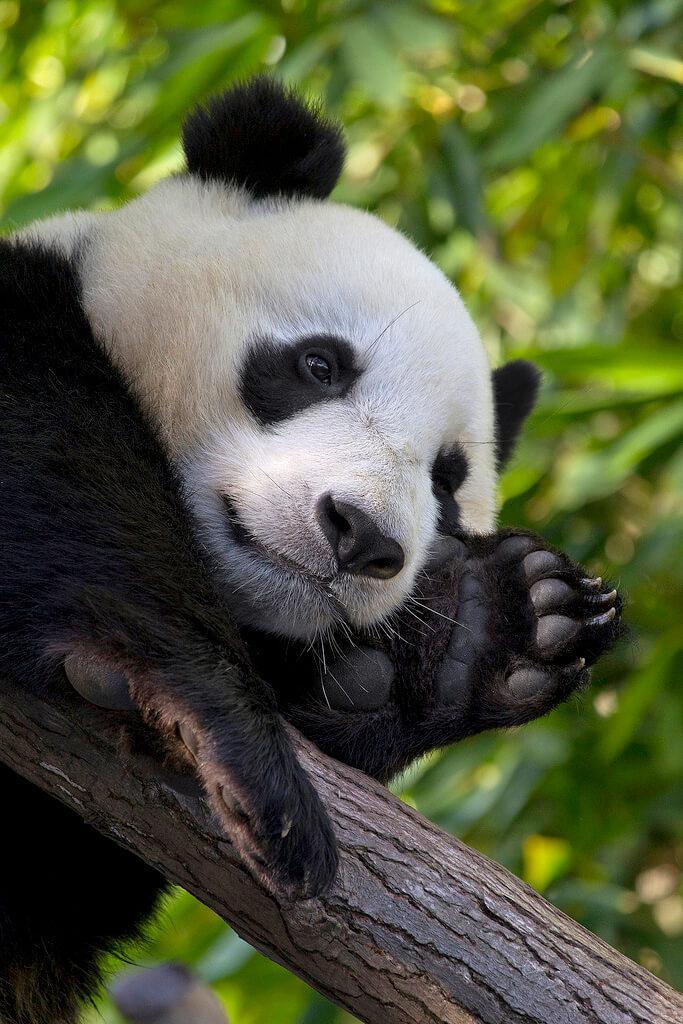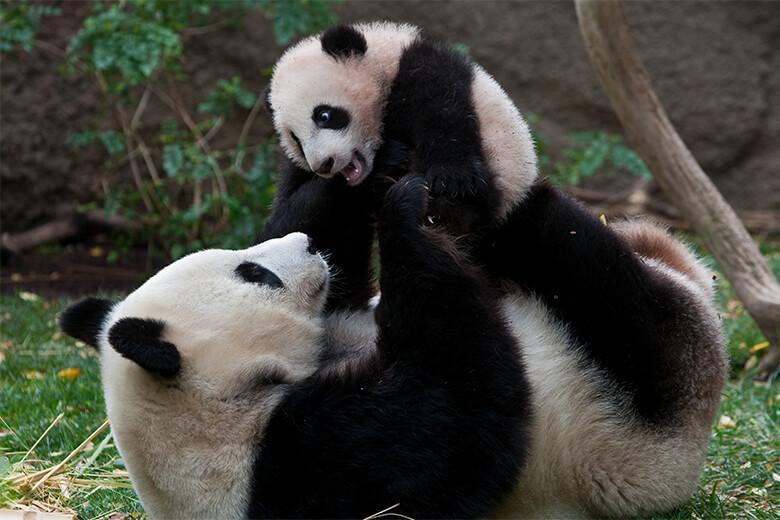The first image is the image on the left, the second image is the image on the right. Considering the images on both sides, is "There are two pandas in the image on the right." valid? Answer yes or no. Yes. 